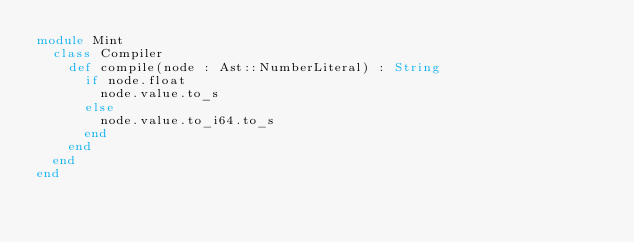<code> <loc_0><loc_0><loc_500><loc_500><_Crystal_>module Mint
  class Compiler
    def compile(node : Ast::NumberLiteral) : String
      if node.float
        node.value.to_s
      else
        node.value.to_i64.to_s
      end
    end
  end
end
</code> 